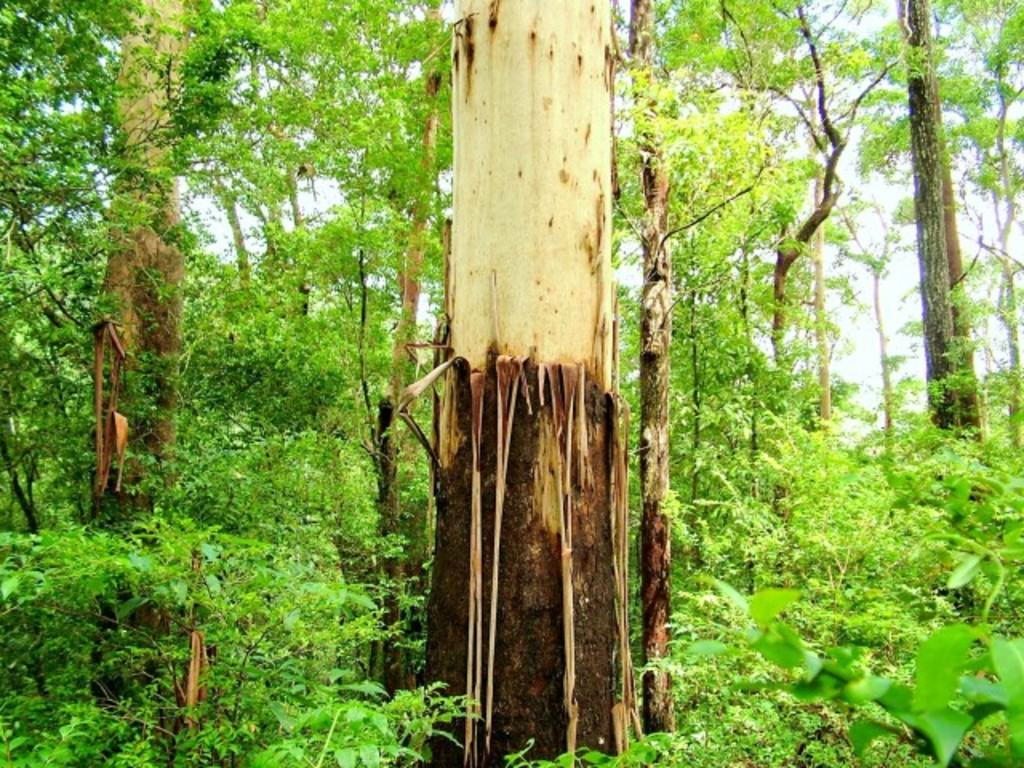What type of natural environment is depicted in the image? There is a forest in the image. What can be found in the forest? The forest is full of trees. What can be seen in the background of the image? The sky is visible in the background of the image. How many oranges are hanging from the trees in the image? There are no oranges present in the image; it depicts a forest full of trees. What type of transportation can be seen traveling through the forest in the image? There are no trains or any other form of transportation visible in the image; it only shows a forest with trees. 